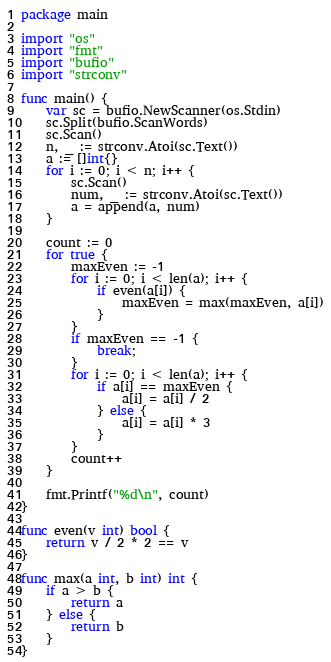<code> <loc_0><loc_0><loc_500><loc_500><_Go_>package main

import "os"
import "fmt"
import "bufio"
import "strconv"

func main() {
    var sc = bufio.NewScanner(os.Stdin)
    sc.Split(bufio.ScanWords)
    sc.Scan()
    n, _ := strconv.Atoi(sc.Text())
    a := []int{}
    for i := 0; i < n; i++ {
        sc.Scan()
        num, _ := strconv.Atoi(sc.Text())
        a = append(a, num)
    }

    count := 0
    for true {
        maxEven := -1
        for i := 0; i < len(a); i++ {
            if even(a[i]) {
                maxEven = max(maxEven, a[i])
            }
        }
        if maxEven == -1 {
            break;
        }
        for i := 0; i < len(a); i++ {
            if a[i] == maxEven {
                a[i] = a[i] / 2
            } else {
                a[i] = a[i] * 3
            }
        }
        count++
    }

    fmt.Printf("%d\n", count)
}

func even(v int) bool {
    return v / 2 * 2 == v
}

func max(a int, b int) int {
    if a > b {
        return a
    } else {
        return b
    }
}
</code> 